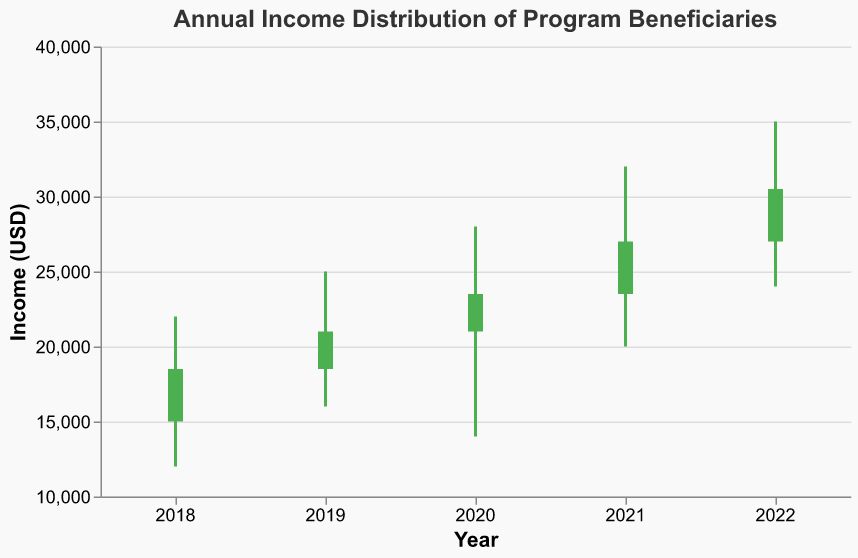What is the highest income recorded in 2020? The highest income recorded in 2020 can be identified by finding the High value for the year 2020. According to the data, the High value for 2020 is 28000.
Answer: 28000 Which year had the lowest opening income? To find the year with the lowest opening income, look for the minimum Open value among all years. The Open values are 15000, 18500, 21000, 23500, and 27000. The lowest value is 15000 in 2018.
Answer: 2018 In which year did the income distribution range (difference between High and Low) show the greatest variability? The income distribution range can be calculated by subtracting the Low value from the High value for each year. The ranges are 10000 (2018), 9000 (2019), 14000 (2020), 12000 (2021), and 11000 (2022). The greatest range is in 2020 with a value of 14000.
Answer: 2020 Compare the closing income of 2019 and 2022. Which year had a higher closing income? To compare the closing incomes of 2019 and 2022, look at the Close values for these years. The Close value is 21000 in 2019 and 30500 in 2022. Since 30500 is higher than 21000, 2022 had a higher closing income.
Answer: 2022 What is the trend in the closing incomes from 2018 to 2022? The trend in closing incomes can be identified by looking at the Close values for each year: 18500 (2018), 21000 (2019), 23500 (2020), 27000 (2021), and 30500 (2022). The Close values show a consistent increase over the years, indicating a positive trend.
Answer: Increasing How much did the closing income increase from 2018 to 2022? The increase in closing income from 2018 to 2022 can be found by subtracting the 2018 Close value from the 2022 Close value. The values are 30500 (2022) and 18500 (2018). The increase is 30500 - 18500 = 12000.
Answer: 12000 Which year had the smallest difference between the opening and closing incomes? The difference between the opening and closing incomes for each year can be calculated. The differences are 3500 (2018), 2500 (2019), 2500 (2020), 3500 (2021), and 3500 (2022). The smallest differences are in 2019 and 2020, both with 2500.
Answer: 2019 and 2020 How does the income distribution in 2021 compare to 2020 in terms of variability? The variability in income distribution can be measured by the range (High - Low). For 2021, the range is 32000 - 20000 = 12000. For 2020, the range is 28000 - 14000 = 14000. The range in 2020 is higher, indicating greater variability in 2020 compared to 2021.
Answer: 2020 had greater variability Which year had the most significant increase in closing income compared to the previous year? The increase in closing income compared to the previous year can be calculated: 2018-2019 (2500), 2019-2020 (2500), 2020-2021 (3500), and 2021-2022 (3500). The most significant increases are in 2020-2021 and 2021-2022, both with 3500.
Answer: 2020-2021 and 2021-2022 What is the color of the bar for the year 2022, and why is it that color? To determine the color of the bar for 2022, we compare the Open and Close values for that year. Since the Close value (30500) is higher than the Open value (27000), the bar is colored green, indicating an increase.
Answer: Green 